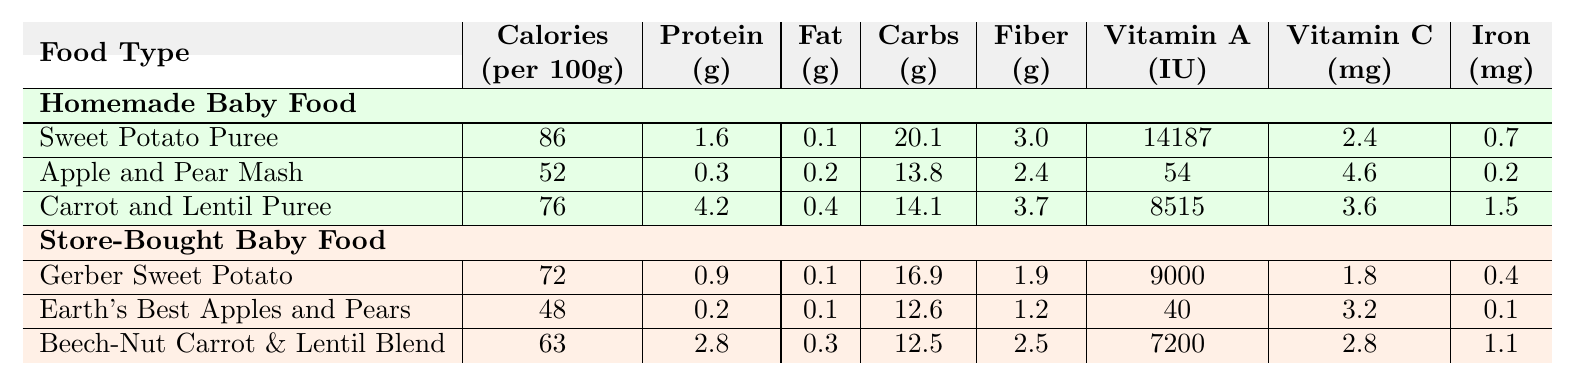What is the calorie count of the Sweet Potato Puree? The table states that the calorie count per 100g of Sweet Potato Puree is 86 calories.
Answer: 86 calories Which has more protein, Apple and Pear Mash or Earth's Best Apples and Pears? The table shows that Apple and Pear Mash contains 0.3 grams of protein, while Earth's Best Apples and Pears contains 0.2 grams. Therefore, Apple and Pear Mash has more protein.
Answer: Apple and Pear Mash What is the total fiber content in the Carrot and Lentil Puree and Beech-Nut Carrot & Lentil Blend combined? From the table, Carrot and Lentil Puree has 3.7 grams of fiber, and Beech-Nut Carrot & Lentil Blend has 2.5 grams of fiber. The total fiber is 3.7 + 2.5 = 6.2 grams.
Answer: 6.2 grams Is there a significant difference in fat content between homemade and store-bought Sweet Potato options? The fat content for homemade Sweet Potato Puree is 0.1 grams, and for store-bought Gerber Sweet Potato, it is also 0.1 grams. Since both values are the same, there is no significant difference.
Answer: No Which item has the highest Vitamin A content? The table lists Sweet Potato Puree with 14187 IU of Vitamin A, which is greater than any other item listed.
Answer: Sweet Potato Puree What is the average carbohydrate content of the homemade baby foods? The carbohydrate content for homemade foods is 20.1 (Sweet Potato Puree) + 13.8 (Apple and Pear Mash) + 14.1 (Carrot and Lentil Puree) = 48 grams. Since there are 3 items, the average is 48 / 3 = 16 grams.
Answer: 16 grams Does the homemade Carrot and Lentil Puree have more iron than Beech-Nut Carrot & Lentil Blend? The table shows that Carrot and Lentil Puree contains 1.5 mg of iron, while Beech-Nut Carrot & Lentil Blend has 1.1 mg. Since 1.5 mg is greater than 1.1 mg, it does have more iron.
Answer: Yes Which has lower vitamin C content, the Apple and Pear Mash or Earth's Best Apples and Pears? The table shows that Apple and Pear Mash contains 4.6 mg of Vitamin C, while Earth's Best Apples and Pears contains 3.2 mg. Therefore, Earth's Best Apples and Pears has lower vitamin C content.
Answer: Earth's Best Apples and Pears What percentage of the calories in the Homemade Sweet Potato Puree come from carbohydrates? Sweet Potato Puree has 86 calories and 20.1 grams of carbohydrates. Since each gram of carbohydrates provides 4 calories, the calories from carbohydrates are 20.1 * 4 = 80.4 calories. The percentage is (80.4 / 86) * 100 = 93.4%.
Answer: 93.4% Which food has the highest fiber content? The table indicates that Carrot and Lentil Puree has 3.7 grams of fiber, which is higher than the fiber content in other foods.
Answer: Carrot and Lentil Puree 